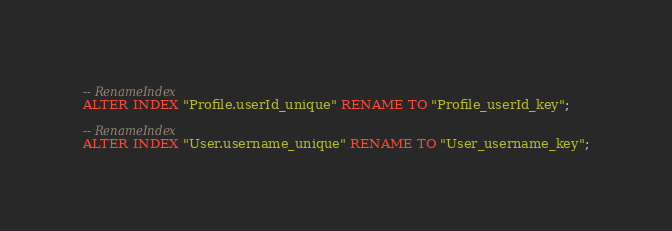<code> <loc_0><loc_0><loc_500><loc_500><_SQL_>-- RenameIndex
ALTER INDEX "Profile.userId_unique" RENAME TO "Profile_userId_key";

-- RenameIndex
ALTER INDEX "User.username_unique" RENAME TO "User_username_key";
</code> 